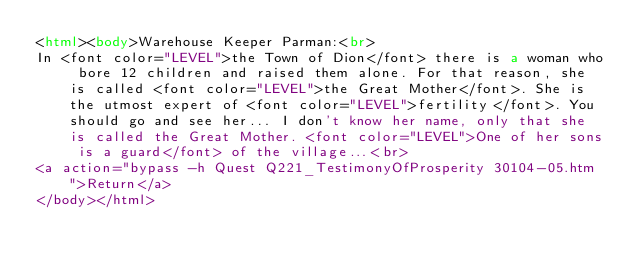Convert code to text. <code><loc_0><loc_0><loc_500><loc_500><_HTML_><html><body>Warehouse Keeper Parman:<br>
In <font color="LEVEL">the Town of Dion</font> there is a woman who bore 12 children and raised them alone. For that reason, she is called <font color="LEVEL">the Great Mother</font>. She is the utmost expert of <font color="LEVEL">fertility</font>. You should go and see her... I don't know her name, only that she is called the Great Mother. <font color="LEVEL">One of her sons is a guard</font> of the village...<br>
<a action="bypass -h Quest Q221_TestimonyOfProsperity 30104-05.htm">Return</a>
</body></html>
</code> 